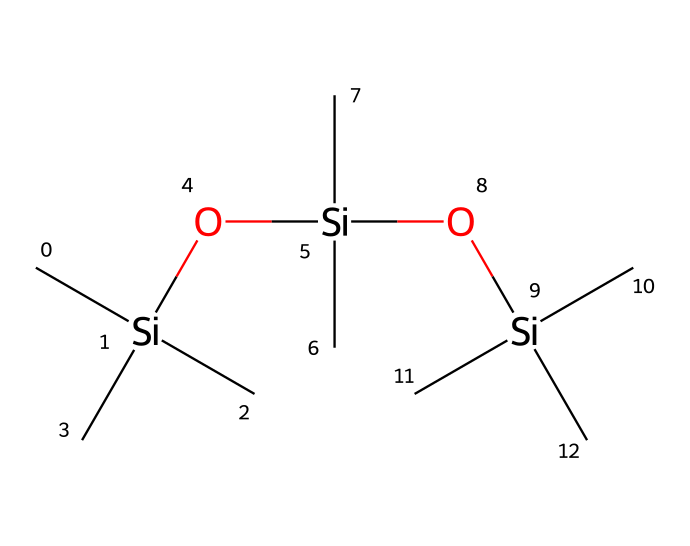how many silicon atoms are present in the compound? In the given SMILES structure, each occurrence of 'Si' corresponds to a silicon atom. There are three 'Si' present in the representation.
Answer: three how many oxygen atoms are present in the compound? The 'O' in the SMILES structure signifies oxygen atoms. In the compound, there are two occurrences of 'O', indicating two oxygen atoms.
Answer: two what type of chemical is represented here? The presence of silicon and carbon organizations along with oxygen atoms characterizes organosilicon compounds. The structure includes multiple Si-C and Si-O linkages.
Answer: organosilicon what is the general property of this structure that makes it useful for waterproof makeup? The extensive Si-O linkages in organosilicon compounds usually lead to high water repellency and stability, traits essential for waterproof formulations.
Answer: water-repellency how many carbon atoms are there in this compound? Each 'C' in the SMILES representation correlates to a carbon atom. There are eight 'C' present throughout the compound, indicating a total of eight carbon atoms.
Answer: eight what makes this compound particularly stable in cosmetic applications? The strong Si-O bonds in the structure contribute to its thermal and mechanical stability, making it suitable for use in cosmetics exposed to heat and humidity.
Answer: stability what kind of functional groups are present in this organosilicon compound? The presence of hydroxyl (-OH) groups attached to silicon through the 'O' indicates that this compound contains silanol functional groups.
Answer: silanol 